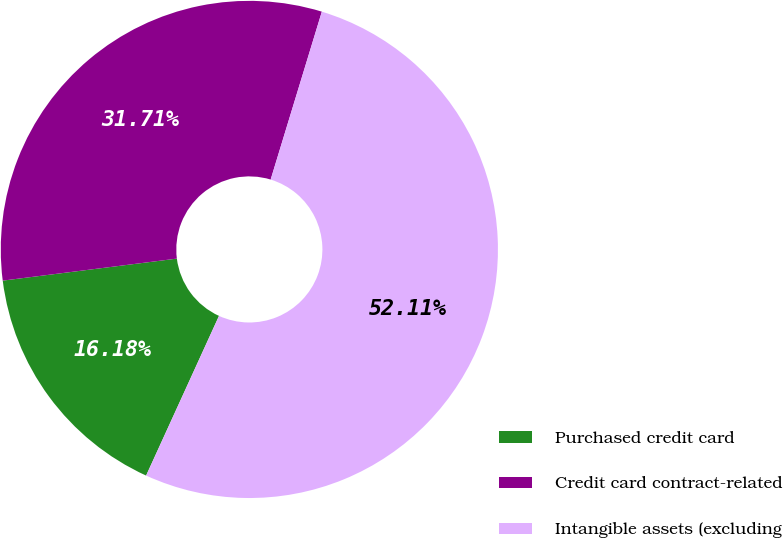Convert chart. <chart><loc_0><loc_0><loc_500><loc_500><pie_chart><fcel>Purchased credit card<fcel>Credit card contract-related<fcel>Intangible assets (excluding<nl><fcel>16.18%<fcel>31.71%<fcel>52.1%<nl></chart> 